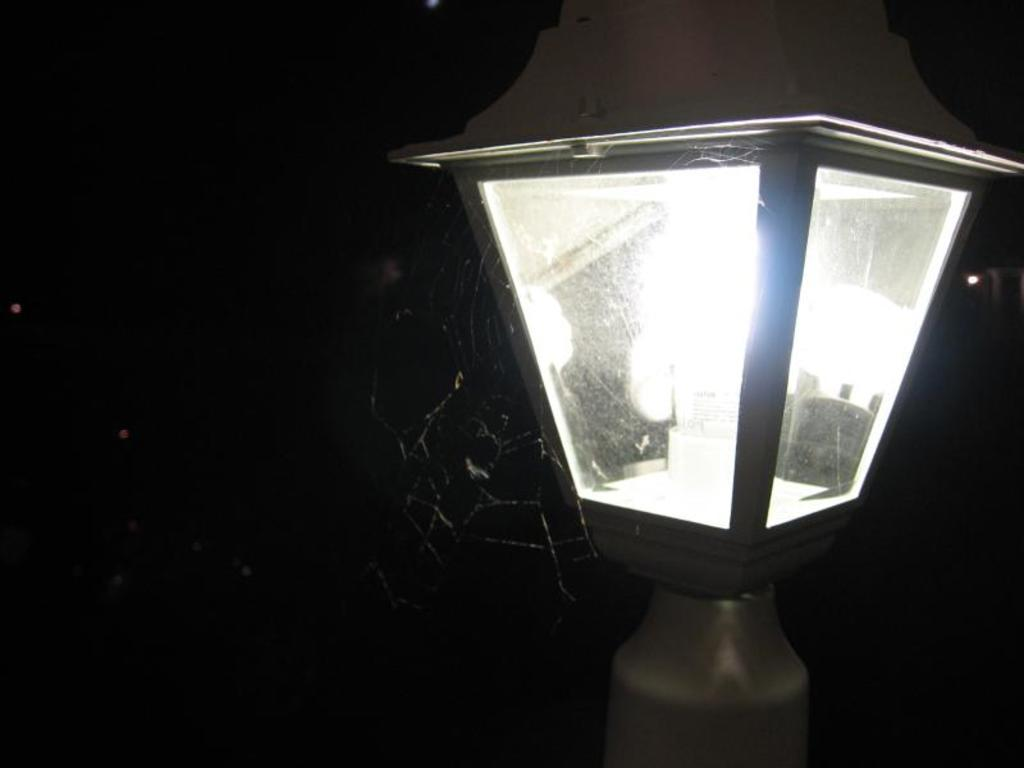What object can be seen in the image? There is a lamp in the image. What color is the background of the image? The background of the image is black. What type of ground can be seen in the image? There is no ground visible in the image, as it only features a lamp against a black background. 